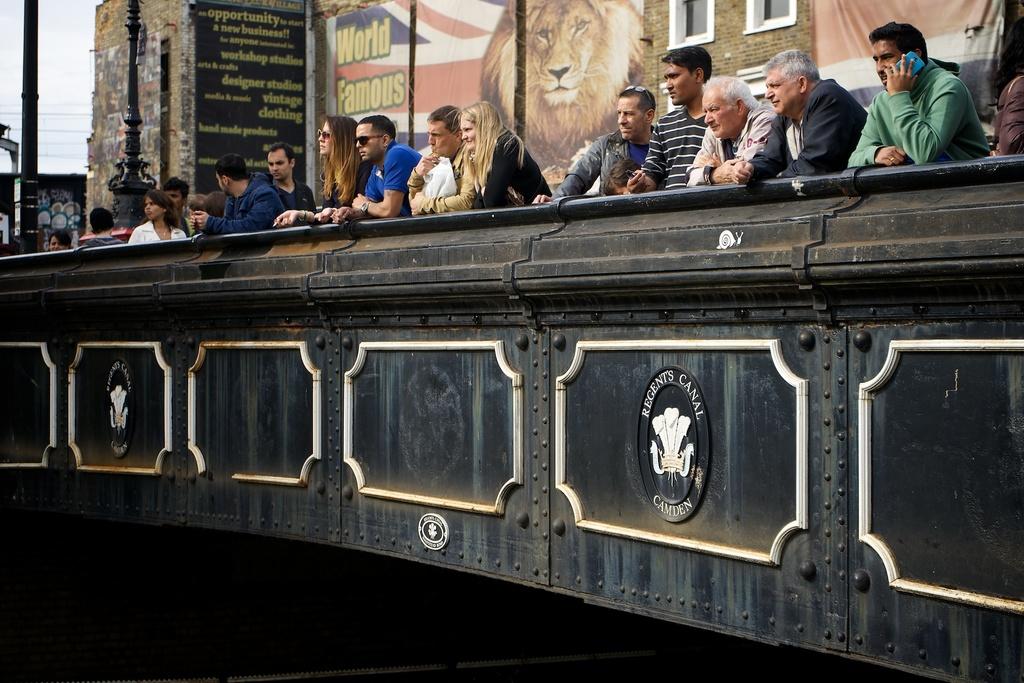How famous is it?
Give a very brief answer. World famous. What text is shown on the seal?
Provide a succinct answer. Regents canal camden. 